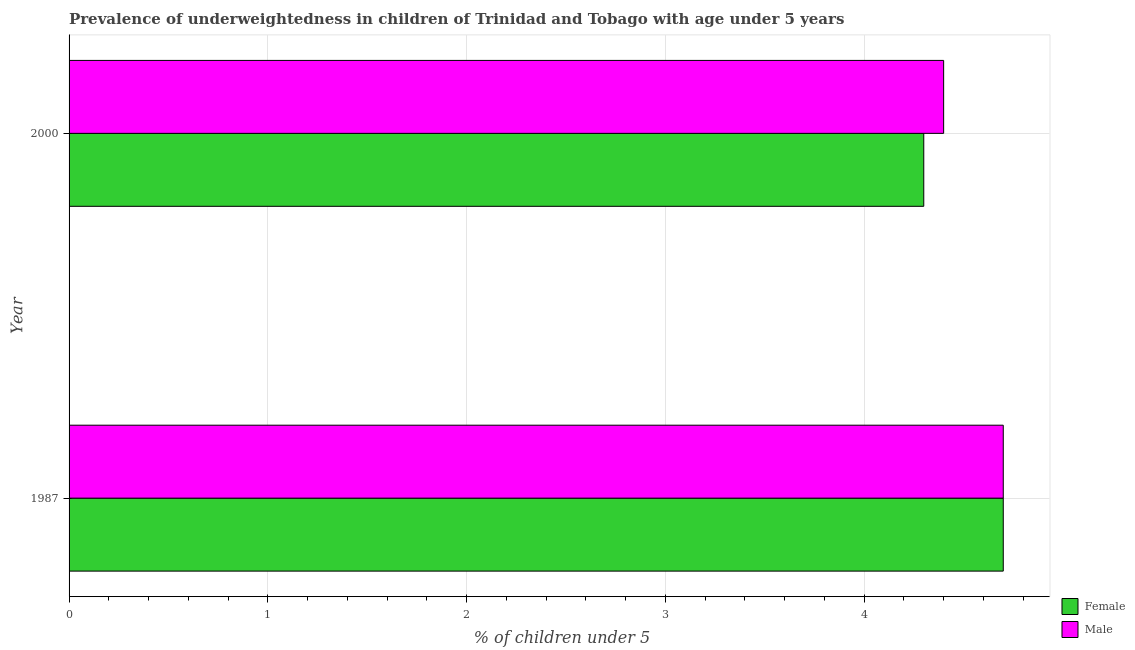How many different coloured bars are there?
Offer a very short reply. 2. How many groups of bars are there?
Give a very brief answer. 2. Are the number of bars per tick equal to the number of legend labels?
Offer a very short reply. Yes. Are the number of bars on each tick of the Y-axis equal?
Provide a succinct answer. Yes. How many bars are there on the 2nd tick from the bottom?
Give a very brief answer. 2. In how many cases, is the number of bars for a given year not equal to the number of legend labels?
Offer a very short reply. 0. What is the percentage of underweighted female children in 2000?
Offer a terse response. 4.3. Across all years, what is the maximum percentage of underweighted female children?
Ensure brevity in your answer.  4.7. Across all years, what is the minimum percentage of underweighted female children?
Your answer should be very brief. 4.3. What is the total percentage of underweighted female children in the graph?
Your answer should be very brief. 9. What is the difference between the percentage of underweighted female children in 2000 and the percentage of underweighted male children in 1987?
Offer a terse response. -0.4. What is the average percentage of underweighted female children per year?
Make the answer very short. 4.5. In the year 1987, what is the difference between the percentage of underweighted female children and percentage of underweighted male children?
Make the answer very short. 0. In how many years, is the percentage of underweighted male children greater than 0.2 %?
Your response must be concise. 2. What is the ratio of the percentage of underweighted female children in 1987 to that in 2000?
Offer a very short reply. 1.09. Is the percentage of underweighted male children in 1987 less than that in 2000?
Keep it short and to the point. No. What does the 2nd bar from the top in 2000 represents?
Keep it short and to the point. Female. What does the 1st bar from the bottom in 2000 represents?
Keep it short and to the point. Female. How many years are there in the graph?
Your answer should be compact. 2. Are the values on the major ticks of X-axis written in scientific E-notation?
Keep it short and to the point. No. Does the graph contain grids?
Your answer should be very brief. Yes. Where does the legend appear in the graph?
Give a very brief answer. Bottom right. What is the title of the graph?
Your answer should be very brief. Prevalence of underweightedness in children of Trinidad and Tobago with age under 5 years. Does "Formally registered" appear as one of the legend labels in the graph?
Your answer should be very brief. No. What is the label or title of the X-axis?
Your answer should be very brief.  % of children under 5. What is the  % of children under 5 of Female in 1987?
Make the answer very short. 4.7. What is the  % of children under 5 in Male in 1987?
Offer a terse response. 4.7. What is the  % of children under 5 in Female in 2000?
Provide a short and direct response. 4.3. What is the  % of children under 5 of Male in 2000?
Offer a very short reply. 4.4. Across all years, what is the maximum  % of children under 5 in Female?
Ensure brevity in your answer.  4.7. Across all years, what is the maximum  % of children under 5 in Male?
Provide a short and direct response. 4.7. Across all years, what is the minimum  % of children under 5 of Female?
Offer a very short reply. 4.3. Across all years, what is the minimum  % of children under 5 in Male?
Keep it short and to the point. 4.4. What is the total  % of children under 5 in Male in the graph?
Your answer should be compact. 9.1. What is the difference between the  % of children under 5 of Female in 1987 and that in 2000?
Offer a very short reply. 0.4. What is the difference between the  % of children under 5 in Female in 1987 and the  % of children under 5 in Male in 2000?
Offer a very short reply. 0.3. What is the average  % of children under 5 in Male per year?
Offer a terse response. 4.55. What is the ratio of the  % of children under 5 of Female in 1987 to that in 2000?
Ensure brevity in your answer.  1.09. What is the ratio of the  % of children under 5 of Male in 1987 to that in 2000?
Your answer should be compact. 1.07. What is the difference between the highest and the second highest  % of children under 5 of Female?
Ensure brevity in your answer.  0.4. What is the difference between the highest and the second highest  % of children under 5 of Male?
Your response must be concise. 0.3. What is the difference between the highest and the lowest  % of children under 5 of Female?
Give a very brief answer. 0.4. What is the difference between the highest and the lowest  % of children under 5 in Male?
Give a very brief answer. 0.3. 